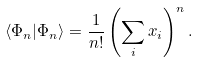<formula> <loc_0><loc_0><loc_500><loc_500>\langle \Phi _ { n } | \Phi _ { n } \rangle = \frac { 1 } { n ! } \left ( \sum _ { i } x _ { i } \right ) ^ { n } .</formula> 